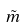Convert formula to latex. <formula><loc_0><loc_0><loc_500><loc_500>\tilde { m }</formula> 